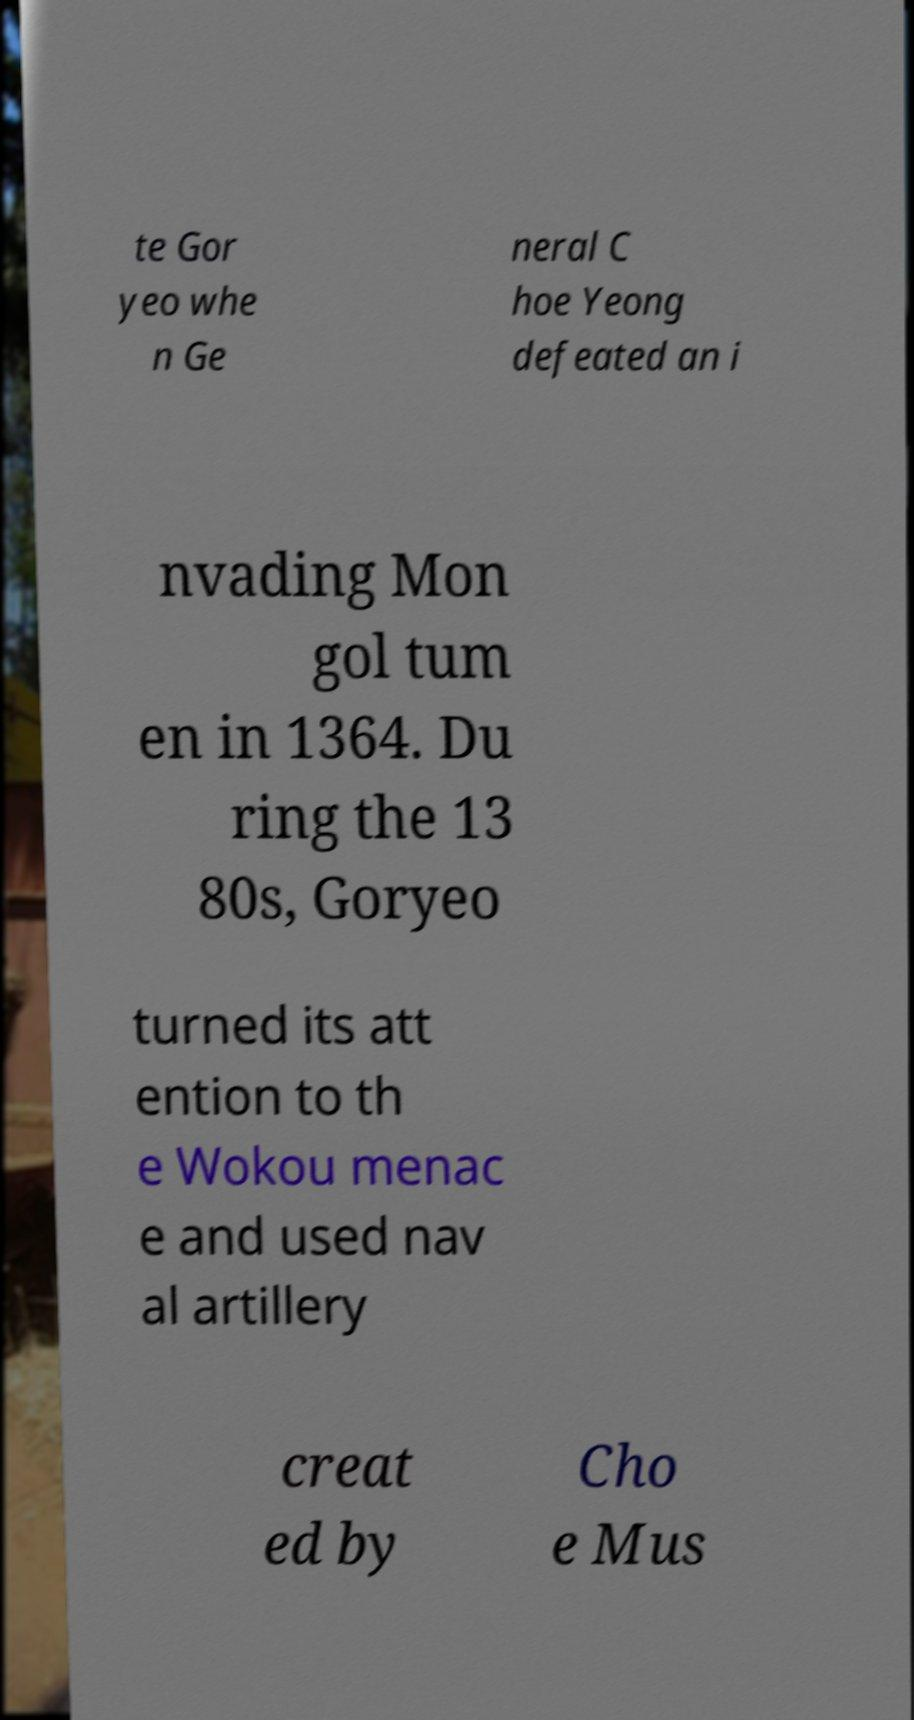Please identify and transcribe the text found in this image. te Gor yeo whe n Ge neral C hoe Yeong defeated an i nvading Mon gol tum en in 1364. Du ring the 13 80s, Goryeo turned its att ention to th e Wokou menac e and used nav al artillery creat ed by Cho e Mus 